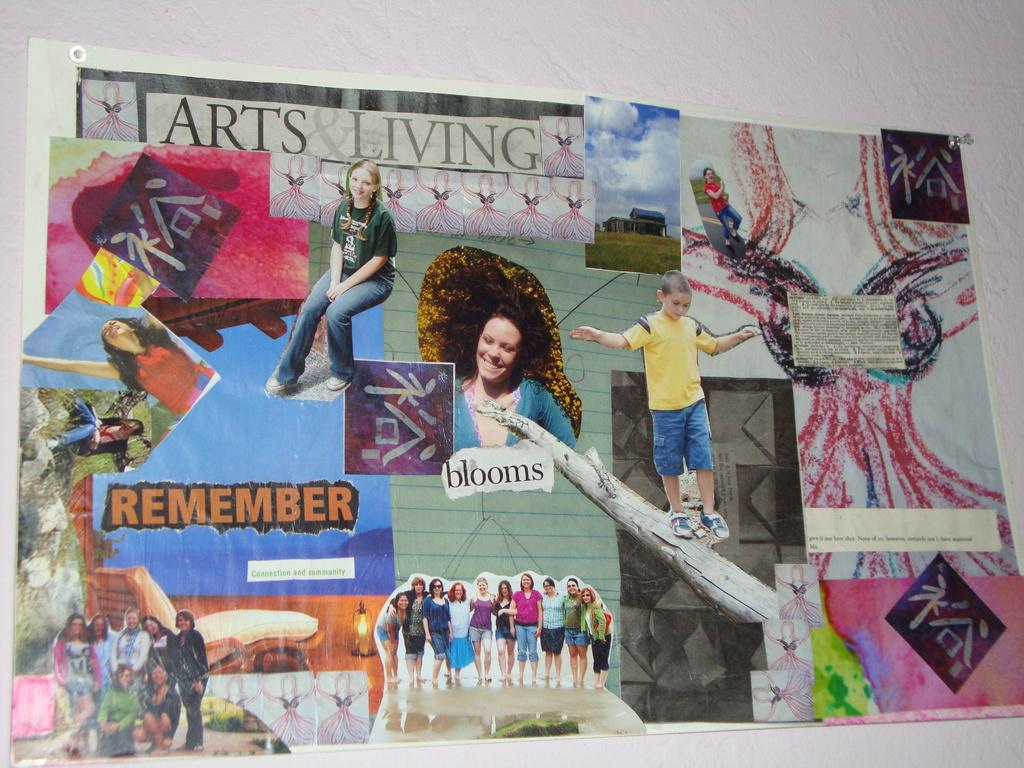<image>
Present a compact description of the photo's key features. A art collage of many random things with the words Arts Living at the top. 